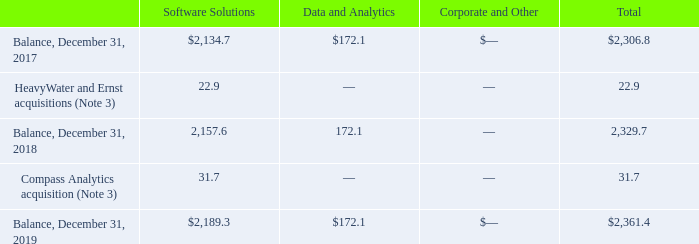(10) Goodwill
Goodwill consists of the following (in millions):
The increase in Goodwill related to our Compass Analytics acquisition is deductible for tax purposes. For the 2018 increase in Goodwill, $19.7 million is deductible for tax purposes and $3.2 million is not deductible for tax purposes.
For the 2018 increase in Goodwill, how much was deductible for tax purposes?
Answer scale should be: million. 19.7. What was the balance in 2017 for Software Solutions?
Answer scale should be: million. 2,134.7. What was the total balance in 2019?
Answer scale should be: million. 2,361.4. What was the change in the balance of software solutions between 2017 and 2018?
Answer scale should be: million. 2,157.6-2,134.7
Answer: 22.9. What was the difference in the total between HeavyWater and Ernst acquisitions and Compass Analytics acquisition?
Answer scale should be: million. 31.7-22.9
Answer: 8.8. What was the percentage change in total balance between 2018 and 2019?
Answer scale should be: percent. (2,361.4-2,329.7)/2,329.7
Answer: 1.36. 